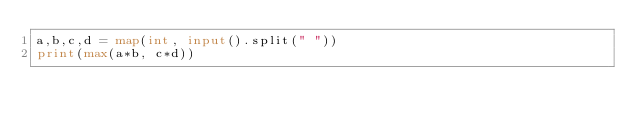<code> <loc_0><loc_0><loc_500><loc_500><_Python_>a,b,c,d = map(int, input().split(" "))
print(max(a*b, c*d))</code> 